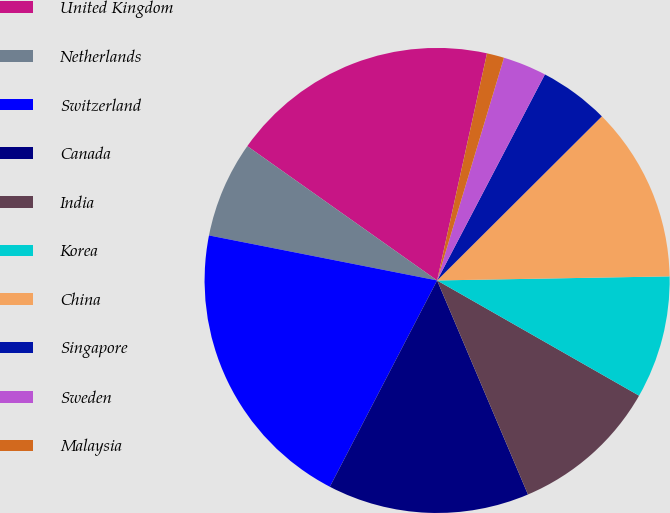Convert chart to OTSL. <chart><loc_0><loc_0><loc_500><loc_500><pie_chart><fcel>United Kingdom<fcel>Netherlands<fcel>Switzerland<fcel>Canada<fcel>India<fcel>Korea<fcel>China<fcel>Singapore<fcel>Sweden<fcel>Malaysia<nl><fcel>18.64%<fcel>6.7%<fcel>20.47%<fcel>14.02%<fcel>10.36%<fcel>8.53%<fcel>12.19%<fcel>4.86%<fcel>3.03%<fcel>1.2%<nl></chart> 